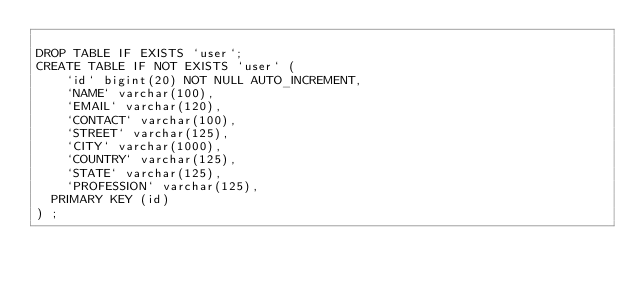Convert code to text. <code><loc_0><loc_0><loc_500><loc_500><_SQL_>
DROP TABLE IF EXISTS `user`;
CREATE TABLE IF NOT EXISTS `user` (
  	`id` bigint(20) NOT NULL AUTO_INCREMENT,
	  `NAME` varchar(100),
   	`EMAIL` varchar(120),
   	`CONTACT` varchar(100),
   	`STREET` varchar(125),
   	`CITY` varchar(1000),
   	`COUNTRY` varchar(125),
   	`STATE` varchar(125),
   	`PROFESSION` varchar(125),
  PRIMARY KEY (id)
) ;
</code> 